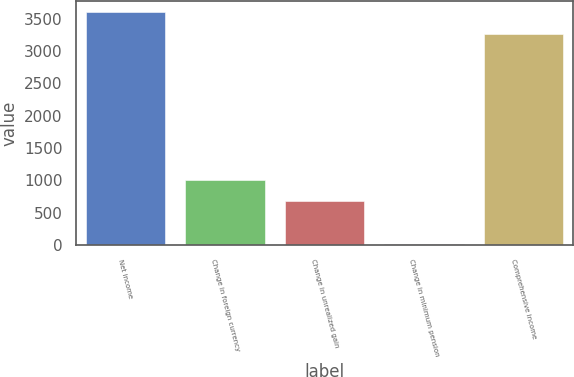Convert chart. <chart><loc_0><loc_0><loc_500><loc_500><bar_chart><fcel>Net income<fcel>Change in foreign currency<fcel>Change in unrealized gain<fcel>Change in minimum pension<fcel>Comprehensive income<nl><fcel>3599.5<fcel>1012.5<fcel>681<fcel>18<fcel>3268<nl></chart> 